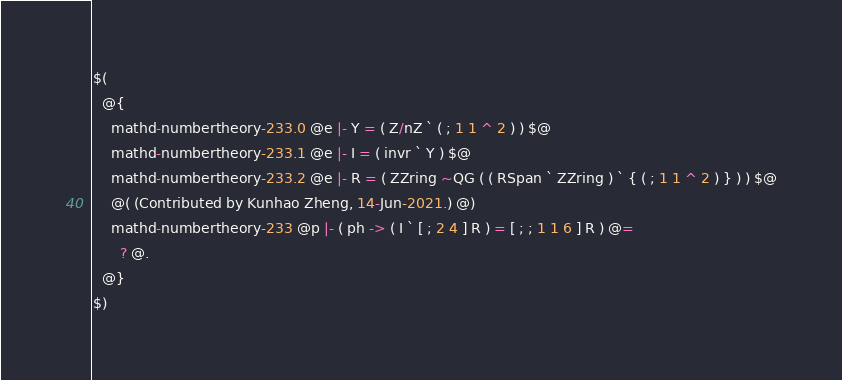<code> <loc_0><loc_0><loc_500><loc_500><_ObjectiveC_>$(
  @{
    mathd-numbertheory-233.0 @e |- Y = ( Z/nZ ` ( ; 1 1 ^ 2 ) ) $@
    mathd-numbertheory-233.1 @e |- I = ( invr ` Y ) $@
    mathd-numbertheory-233.2 @e |- R = ( ZZring ~QG ( ( RSpan ` ZZring ) ` { ( ; 1 1 ^ 2 ) } ) ) $@
    @( (Contributed by Kunhao Zheng, 14-Jun-2021.) @)
    mathd-numbertheory-233 @p |- ( ph -> ( I ` [ ; 2 4 ] R ) = [ ; ; 1 1 6 ] R ) @=
      ? @.
  @}
$)
</code> 